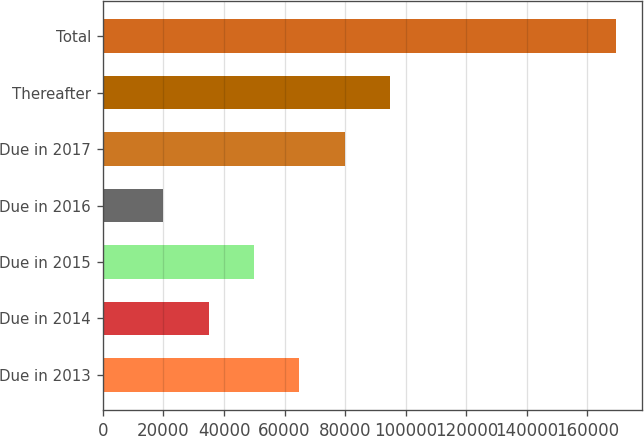Convert chart to OTSL. <chart><loc_0><loc_0><loc_500><loc_500><bar_chart><fcel>Due in 2013<fcel>Due in 2014<fcel>Due in 2015<fcel>Due in 2016<fcel>Due in 2017<fcel>Thereafter<fcel>Total<nl><fcel>64860.1<fcel>34942.7<fcel>49901.4<fcel>19984<fcel>79818.8<fcel>94777.5<fcel>169571<nl></chart> 